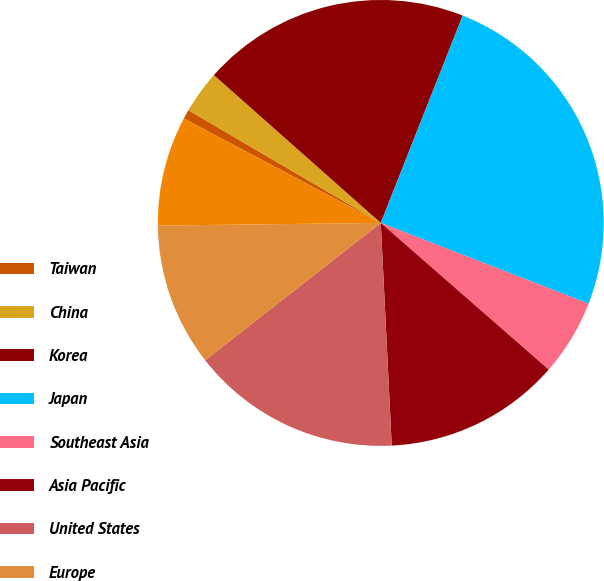Convert chart. <chart><loc_0><loc_0><loc_500><loc_500><pie_chart><fcel>Taiwan<fcel>China<fcel>Korea<fcel>Japan<fcel>Southeast Asia<fcel>Asia Pacific<fcel>United States<fcel>Europe<fcel>Total<nl><fcel>0.68%<fcel>3.1%<fcel>19.45%<fcel>24.91%<fcel>5.53%<fcel>12.79%<fcel>15.22%<fcel>10.37%<fcel>7.95%<nl></chart> 